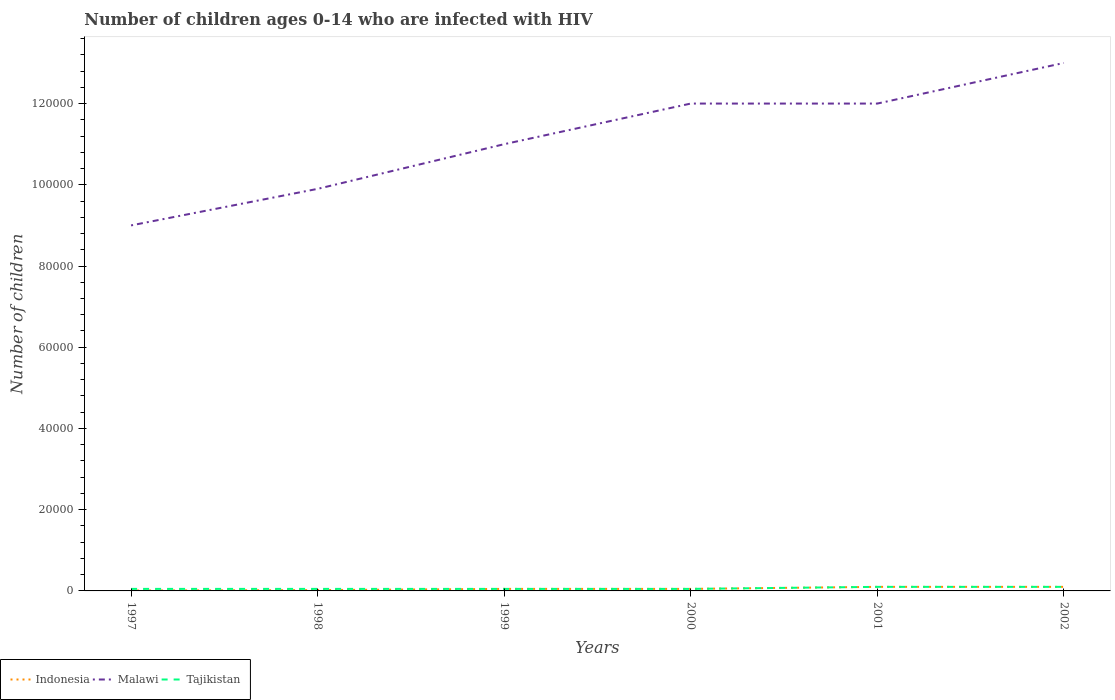Does the line corresponding to Malawi intersect with the line corresponding to Tajikistan?
Keep it short and to the point. No. Across all years, what is the maximum number of HIV infected children in Tajikistan?
Provide a succinct answer. 500. What is the total number of HIV infected children in Indonesia in the graph?
Give a very brief answer. -100. What is the difference between the highest and the second highest number of HIV infected children in Malawi?
Keep it short and to the point. 4.00e+04. How many lines are there?
Provide a succinct answer. 3. What is the difference between two consecutive major ticks on the Y-axis?
Your answer should be compact. 2.00e+04. Does the graph contain any zero values?
Make the answer very short. No. Does the graph contain grids?
Provide a short and direct response. No. Where does the legend appear in the graph?
Make the answer very short. Bottom left. How many legend labels are there?
Make the answer very short. 3. What is the title of the graph?
Make the answer very short. Number of children ages 0-14 who are infected with HIV. What is the label or title of the X-axis?
Provide a short and direct response. Years. What is the label or title of the Y-axis?
Offer a very short reply. Number of children. What is the Number of children in Malawi in 1998?
Offer a terse response. 9.90e+04. What is the Number of children of Tajikistan in 1998?
Give a very brief answer. 500. What is the Number of children of Tajikistan in 1999?
Provide a succinct answer. 500. What is the Number of children in Indonesia in 2000?
Keep it short and to the point. 500. What is the Number of children in Indonesia in 2001?
Make the answer very short. 1000. What is the Number of children of Malawi in 2001?
Offer a very short reply. 1.20e+05. What is the Number of children of Tajikistan in 2001?
Your answer should be very brief. 1000. What is the Number of children in Indonesia in 2002?
Your response must be concise. 1000. Across all years, what is the maximum Number of children in Tajikistan?
Offer a terse response. 1000. Across all years, what is the minimum Number of children in Indonesia?
Make the answer very short. 100. Across all years, what is the minimum Number of children in Malawi?
Ensure brevity in your answer.  9.00e+04. Across all years, what is the minimum Number of children of Tajikistan?
Offer a very short reply. 500. What is the total Number of children of Indonesia in the graph?
Your answer should be very brief. 3300. What is the total Number of children in Malawi in the graph?
Offer a terse response. 6.69e+05. What is the total Number of children in Tajikistan in the graph?
Provide a succinct answer. 4000. What is the difference between the Number of children of Indonesia in 1997 and that in 1998?
Provide a succinct answer. -100. What is the difference between the Number of children of Malawi in 1997 and that in 1998?
Ensure brevity in your answer.  -9000. What is the difference between the Number of children of Indonesia in 1997 and that in 1999?
Give a very brief answer. -400. What is the difference between the Number of children in Malawi in 1997 and that in 1999?
Ensure brevity in your answer.  -2.00e+04. What is the difference between the Number of children of Tajikistan in 1997 and that in 1999?
Make the answer very short. 0. What is the difference between the Number of children in Indonesia in 1997 and that in 2000?
Provide a short and direct response. -400. What is the difference between the Number of children of Indonesia in 1997 and that in 2001?
Make the answer very short. -900. What is the difference between the Number of children in Tajikistan in 1997 and that in 2001?
Keep it short and to the point. -500. What is the difference between the Number of children in Indonesia in 1997 and that in 2002?
Offer a very short reply. -900. What is the difference between the Number of children in Malawi in 1997 and that in 2002?
Offer a terse response. -4.00e+04. What is the difference between the Number of children in Tajikistan in 1997 and that in 2002?
Your response must be concise. -500. What is the difference between the Number of children of Indonesia in 1998 and that in 1999?
Give a very brief answer. -300. What is the difference between the Number of children in Malawi in 1998 and that in 1999?
Your answer should be compact. -1.10e+04. What is the difference between the Number of children of Tajikistan in 1998 and that in 1999?
Ensure brevity in your answer.  0. What is the difference between the Number of children in Indonesia in 1998 and that in 2000?
Make the answer very short. -300. What is the difference between the Number of children of Malawi in 1998 and that in 2000?
Provide a short and direct response. -2.10e+04. What is the difference between the Number of children of Tajikistan in 1998 and that in 2000?
Ensure brevity in your answer.  0. What is the difference between the Number of children of Indonesia in 1998 and that in 2001?
Your answer should be compact. -800. What is the difference between the Number of children in Malawi in 1998 and that in 2001?
Ensure brevity in your answer.  -2.10e+04. What is the difference between the Number of children in Tajikistan in 1998 and that in 2001?
Offer a very short reply. -500. What is the difference between the Number of children in Indonesia in 1998 and that in 2002?
Provide a succinct answer. -800. What is the difference between the Number of children of Malawi in 1998 and that in 2002?
Give a very brief answer. -3.10e+04. What is the difference between the Number of children in Tajikistan in 1998 and that in 2002?
Your answer should be compact. -500. What is the difference between the Number of children of Indonesia in 1999 and that in 2000?
Your answer should be very brief. 0. What is the difference between the Number of children of Malawi in 1999 and that in 2000?
Provide a succinct answer. -10000. What is the difference between the Number of children in Tajikistan in 1999 and that in 2000?
Your answer should be very brief. 0. What is the difference between the Number of children of Indonesia in 1999 and that in 2001?
Provide a succinct answer. -500. What is the difference between the Number of children in Tajikistan in 1999 and that in 2001?
Offer a very short reply. -500. What is the difference between the Number of children in Indonesia in 1999 and that in 2002?
Make the answer very short. -500. What is the difference between the Number of children of Tajikistan in 1999 and that in 2002?
Ensure brevity in your answer.  -500. What is the difference between the Number of children in Indonesia in 2000 and that in 2001?
Offer a terse response. -500. What is the difference between the Number of children of Tajikistan in 2000 and that in 2001?
Make the answer very short. -500. What is the difference between the Number of children in Indonesia in 2000 and that in 2002?
Ensure brevity in your answer.  -500. What is the difference between the Number of children in Tajikistan in 2000 and that in 2002?
Make the answer very short. -500. What is the difference between the Number of children of Indonesia in 2001 and that in 2002?
Your answer should be compact. 0. What is the difference between the Number of children of Malawi in 2001 and that in 2002?
Give a very brief answer. -10000. What is the difference between the Number of children of Tajikistan in 2001 and that in 2002?
Offer a terse response. 0. What is the difference between the Number of children of Indonesia in 1997 and the Number of children of Malawi in 1998?
Keep it short and to the point. -9.89e+04. What is the difference between the Number of children in Indonesia in 1997 and the Number of children in Tajikistan in 1998?
Keep it short and to the point. -400. What is the difference between the Number of children of Malawi in 1997 and the Number of children of Tajikistan in 1998?
Give a very brief answer. 8.95e+04. What is the difference between the Number of children of Indonesia in 1997 and the Number of children of Malawi in 1999?
Your answer should be compact. -1.10e+05. What is the difference between the Number of children in Indonesia in 1997 and the Number of children in Tajikistan in 1999?
Offer a terse response. -400. What is the difference between the Number of children in Malawi in 1997 and the Number of children in Tajikistan in 1999?
Your response must be concise. 8.95e+04. What is the difference between the Number of children of Indonesia in 1997 and the Number of children of Malawi in 2000?
Provide a short and direct response. -1.20e+05. What is the difference between the Number of children of Indonesia in 1997 and the Number of children of Tajikistan in 2000?
Make the answer very short. -400. What is the difference between the Number of children of Malawi in 1997 and the Number of children of Tajikistan in 2000?
Offer a very short reply. 8.95e+04. What is the difference between the Number of children of Indonesia in 1997 and the Number of children of Malawi in 2001?
Ensure brevity in your answer.  -1.20e+05. What is the difference between the Number of children in Indonesia in 1997 and the Number of children in Tajikistan in 2001?
Give a very brief answer. -900. What is the difference between the Number of children of Malawi in 1997 and the Number of children of Tajikistan in 2001?
Offer a very short reply. 8.90e+04. What is the difference between the Number of children in Indonesia in 1997 and the Number of children in Malawi in 2002?
Your response must be concise. -1.30e+05. What is the difference between the Number of children in Indonesia in 1997 and the Number of children in Tajikistan in 2002?
Offer a terse response. -900. What is the difference between the Number of children in Malawi in 1997 and the Number of children in Tajikistan in 2002?
Provide a short and direct response. 8.90e+04. What is the difference between the Number of children of Indonesia in 1998 and the Number of children of Malawi in 1999?
Make the answer very short. -1.10e+05. What is the difference between the Number of children in Indonesia in 1998 and the Number of children in Tajikistan in 1999?
Provide a short and direct response. -300. What is the difference between the Number of children in Malawi in 1998 and the Number of children in Tajikistan in 1999?
Make the answer very short. 9.85e+04. What is the difference between the Number of children of Indonesia in 1998 and the Number of children of Malawi in 2000?
Provide a succinct answer. -1.20e+05. What is the difference between the Number of children of Indonesia in 1998 and the Number of children of Tajikistan in 2000?
Offer a very short reply. -300. What is the difference between the Number of children in Malawi in 1998 and the Number of children in Tajikistan in 2000?
Your answer should be very brief. 9.85e+04. What is the difference between the Number of children in Indonesia in 1998 and the Number of children in Malawi in 2001?
Make the answer very short. -1.20e+05. What is the difference between the Number of children in Indonesia in 1998 and the Number of children in Tajikistan in 2001?
Provide a succinct answer. -800. What is the difference between the Number of children in Malawi in 1998 and the Number of children in Tajikistan in 2001?
Offer a very short reply. 9.80e+04. What is the difference between the Number of children of Indonesia in 1998 and the Number of children of Malawi in 2002?
Keep it short and to the point. -1.30e+05. What is the difference between the Number of children in Indonesia in 1998 and the Number of children in Tajikistan in 2002?
Your response must be concise. -800. What is the difference between the Number of children of Malawi in 1998 and the Number of children of Tajikistan in 2002?
Provide a short and direct response. 9.80e+04. What is the difference between the Number of children of Indonesia in 1999 and the Number of children of Malawi in 2000?
Ensure brevity in your answer.  -1.20e+05. What is the difference between the Number of children in Malawi in 1999 and the Number of children in Tajikistan in 2000?
Ensure brevity in your answer.  1.10e+05. What is the difference between the Number of children in Indonesia in 1999 and the Number of children in Malawi in 2001?
Ensure brevity in your answer.  -1.20e+05. What is the difference between the Number of children in Indonesia in 1999 and the Number of children in Tajikistan in 2001?
Your answer should be very brief. -500. What is the difference between the Number of children of Malawi in 1999 and the Number of children of Tajikistan in 2001?
Your answer should be very brief. 1.09e+05. What is the difference between the Number of children of Indonesia in 1999 and the Number of children of Malawi in 2002?
Make the answer very short. -1.30e+05. What is the difference between the Number of children of Indonesia in 1999 and the Number of children of Tajikistan in 2002?
Provide a succinct answer. -500. What is the difference between the Number of children in Malawi in 1999 and the Number of children in Tajikistan in 2002?
Your answer should be compact. 1.09e+05. What is the difference between the Number of children of Indonesia in 2000 and the Number of children of Malawi in 2001?
Provide a short and direct response. -1.20e+05. What is the difference between the Number of children in Indonesia in 2000 and the Number of children in Tajikistan in 2001?
Provide a succinct answer. -500. What is the difference between the Number of children in Malawi in 2000 and the Number of children in Tajikistan in 2001?
Provide a short and direct response. 1.19e+05. What is the difference between the Number of children in Indonesia in 2000 and the Number of children in Malawi in 2002?
Provide a succinct answer. -1.30e+05. What is the difference between the Number of children of Indonesia in 2000 and the Number of children of Tajikistan in 2002?
Offer a very short reply. -500. What is the difference between the Number of children of Malawi in 2000 and the Number of children of Tajikistan in 2002?
Give a very brief answer. 1.19e+05. What is the difference between the Number of children of Indonesia in 2001 and the Number of children of Malawi in 2002?
Provide a short and direct response. -1.29e+05. What is the difference between the Number of children in Indonesia in 2001 and the Number of children in Tajikistan in 2002?
Give a very brief answer. 0. What is the difference between the Number of children in Malawi in 2001 and the Number of children in Tajikistan in 2002?
Offer a very short reply. 1.19e+05. What is the average Number of children in Indonesia per year?
Ensure brevity in your answer.  550. What is the average Number of children of Malawi per year?
Keep it short and to the point. 1.12e+05. What is the average Number of children of Tajikistan per year?
Your answer should be very brief. 666.67. In the year 1997, what is the difference between the Number of children of Indonesia and Number of children of Malawi?
Ensure brevity in your answer.  -8.99e+04. In the year 1997, what is the difference between the Number of children of Indonesia and Number of children of Tajikistan?
Your response must be concise. -400. In the year 1997, what is the difference between the Number of children of Malawi and Number of children of Tajikistan?
Offer a terse response. 8.95e+04. In the year 1998, what is the difference between the Number of children of Indonesia and Number of children of Malawi?
Give a very brief answer. -9.88e+04. In the year 1998, what is the difference between the Number of children of Indonesia and Number of children of Tajikistan?
Provide a short and direct response. -300. In the year 1998, what is the difference between the Number of children in Malawi and Number of children in Tajikistan?
Your answer should be very brief. 9.85e+04. In the year 1999, what is the difference between the Number of children of Indonesia and Number of children of Malawi?
Your answer should be very brief. -1.10e+05. In the year 1999, what is the difference between the Number of children in Malawi and Number of children in Tajikistan?
Keep it short and to the point. 1.10e+05. In the year 2000, what is the difference between the Number of children of Indonesia and Number of children of Malawi?
Offer a very short reply. -1.20e+05. In the year 2000, what is the difference between the Number of children in Indonesia and Number of children in Tajikistan?
Your response must be concise. 0. In the year 2000, what is the difference between the Number of children in Malawi and Number of children in Tajikistan?
Your answer should be compact. 1.20e+05. In the year 2001, what is the difference between the Number of children in Indonesia and Number of children in Malawi?
Ensure brevity in your answer.  -1.19e+05. In the year 2001, what is the difference between the Number of children of Indonesia and Number of children of Tajikistan?
Ensure brevity in your answer.  0. In the year 2001, what is the difference between the Number of children of Malawi and Number of children of Tajikistan?
Your answer should be compact. 1.19e+05. In the year 2002, what is the difference between the Number of children in Indonesia and Number of children in Malawi?
Make the answer very short. -1.29e+05. In the year 2002, what is the difference between the Number of children of Malawi and Number of children of Tajikistan?
Your answer should be very brief. 1.29e+05. What is the ratio of the Number of children in Malawi in 1997 to that in 1998?
Provide a short and direct response. 0.91. What is the ratio of the Number of children of Indonesia in 1997 to that in 1999?
Your answer should be very brief. 0.2. What is the ratio of the Number of children of Malawi in 1997 to that in 1999?
Your answer should be very brief. 0.82. What is the ratio of the Number of children of Malawi in 1997 to that in 2000?
Keep it short and to the point. 0.75. What is the ratio of the Number of children in Indonesia in 1997 to that in 2001?
Offer a very short reply. 0.1. What is the ratio of the Number of children in Malawi in 1997 to that in 2001?
Give a very brief answer. 0.75. What is the ratio of the Number of children of Indonesia in 1997 to that in 2002?
Give a very brief answer. 0.1. What is the ratio of the Number of children of Malawi in 1997 to that in 2002?
Provide a short and direct response. 0.69. What is the ratio of the Number of children in Indonesia in 1998 to that in 1999?
Provide a short and direct response. 0.4. What is the ratio of the Number of children of Malawi in 1998 to that in 1999?
Give a very brief answer. 0.9. What is the ratio of the Number of children of Tajikistan in 1998 to that in 1999?
Offer a very short reply. 1. What is the ratio of the Number of children in Indonesia in 1998 to that in 2000?
Offer a very short reply. 0.4. What is the ratio of the Number of children of Malawi in 1998 to that in 2000?
Offer a very short reply. 0.82. What is the ratio of the Number of children of Malawi in 1998 to that in 2001?
Ensure brevity in your answer.  0.82. What is the ratio of the Number of children in Tajikistan in 1998 to that in 2001?
Your response must be concise. 0.5. What is the ratio of the Number of children in Malawi in 1998 to that in 2002?
Offer a very short reply. 0.76. What is the ratio of the Number of children in Tajikistan in 1998 to that in 2002?
Your response must be concise. 0.5. What is the ratio of the Number of children of Indonesia in 1999 to that in 2000?
Provide a short and direct response. 1. What is the ratio of the Number of children in Malawi in 1999 to that in 2000?
Make the answer very short. 0.92. What is the ratio of the Number of children in Indonesia in 1999 to that in 2001?
Provide a succinct answer. 0.5. What is the ratio of the Number of children of Malawi in 1999 to that in 2001?
Offer a very short reply. 0.92. What is the ratio of the Number of children of Tajikistan in 1999 to that in 2001?
Give a very brief answer. 0.5. What is the ratio of the Number of children in Malawi in 1999 to that in 2002?
Your response must be concise. 0.85. What is the ratio of the Number of children in Indonesia in 2000 to that in 2001?
Provide a short and direct response. 0.5. What is the ratio of the Number of children in Malawi in 2000 to that in 2002?
Keep it short and to the point. 0.92. What is the ratio of the Number of children in Malawi in 2001 to that in 2002?
Make the answer very short. 0.92. What is the ratio of the Number of children of Tajikistan in 2001 to that in 2002?
Your response must be concise. 1. What is the difference between the highest and the second highest Number of children of Tajikistan?
Give a very brief answer. 0. What is the difference between the highest and the lowest Number of children in Indonesia?
Provide a succinct answer. 900. 